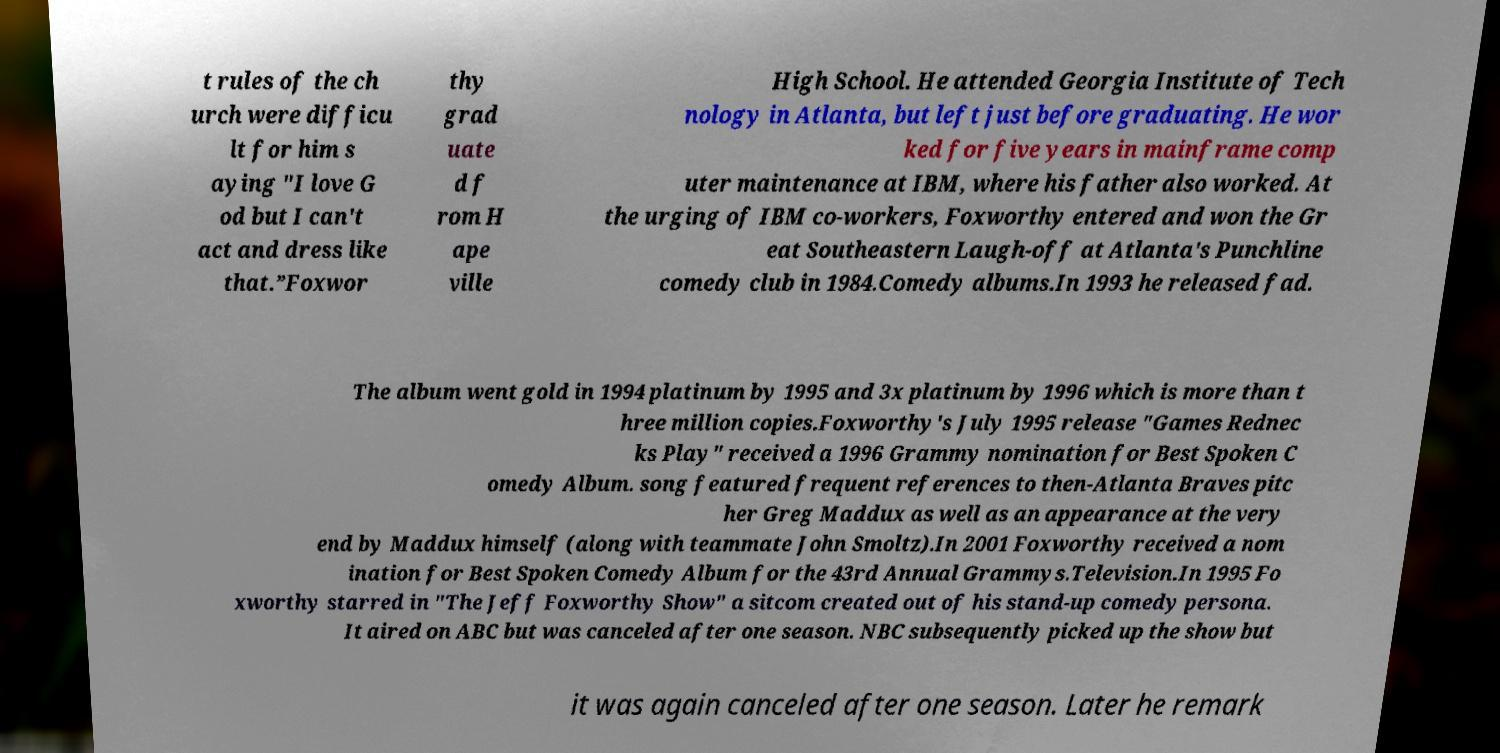What messages or text are displayed in this image? I need them in a readable, typed format. t rules of the ch urch were difficu lt for him s aying "I love G od but I can't act and dress like that.”Foxwor thy grad uate d f rom H ape ville High School. He attended Georgia Institute of Tech nology in Atlanta, but left just before graduating. He wor ked for five years in mainframe comp uter maintenance at IBM, where his father also worked. At the urging of IBM co-workers, Foxworthy entered and won the Gr eat Southeastern Laugh-off at Atlanta's Punchline comedy club in 1984.Comedy albums.In 1993 he released fad. The album went gold in 1994 platinum by 1995 and 3x platinum by 1996 which is more than t hree million copies.Foxworthy's July 1995 release "Games Rednec ks Play" received a 1996 Grammy nomination for Best Spoken C omedy Album. song featured frequent references to then-Atlanta Braves pitc her Greg Maddux as well as an appearance at the very end by Maddux himself (along with teammate John Smoltz).In 2001 Foxworthy received a nom ination for Best Spoken Comedy Album for the 43rd Annual Grammys.Television.In 1995 Fo xworthy starred in "The Jeff Foxworthy Show" a sitcom created out of his stand-up comedy persona. It aired on ABC but was canceled after one season. NBC subsequently picked up the show but it was again canceled after one season. Later he remark 